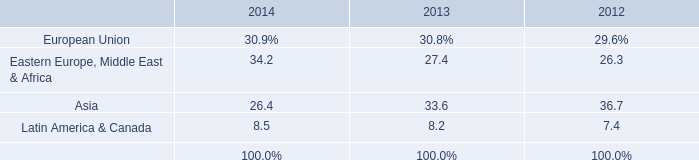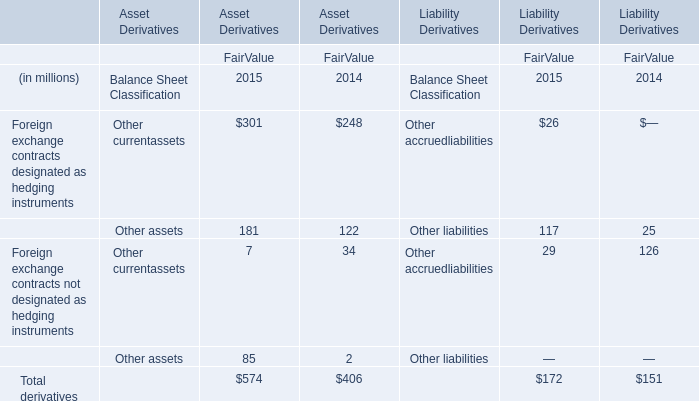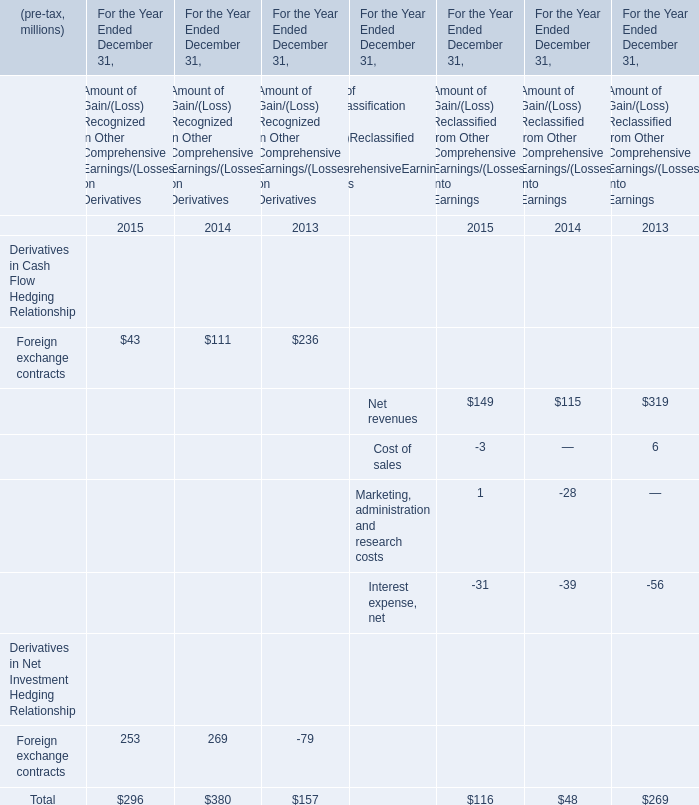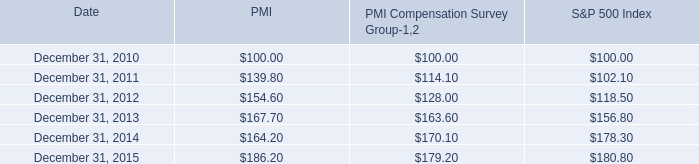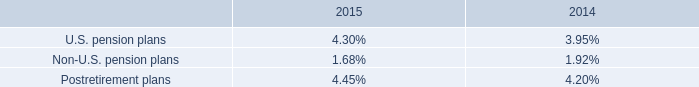what is the roi of an investment in s&p 500 in 2010 and liquidated in 2011? 
Computations: ((102.10 - 100) / 100)
Answer: 0.021. 